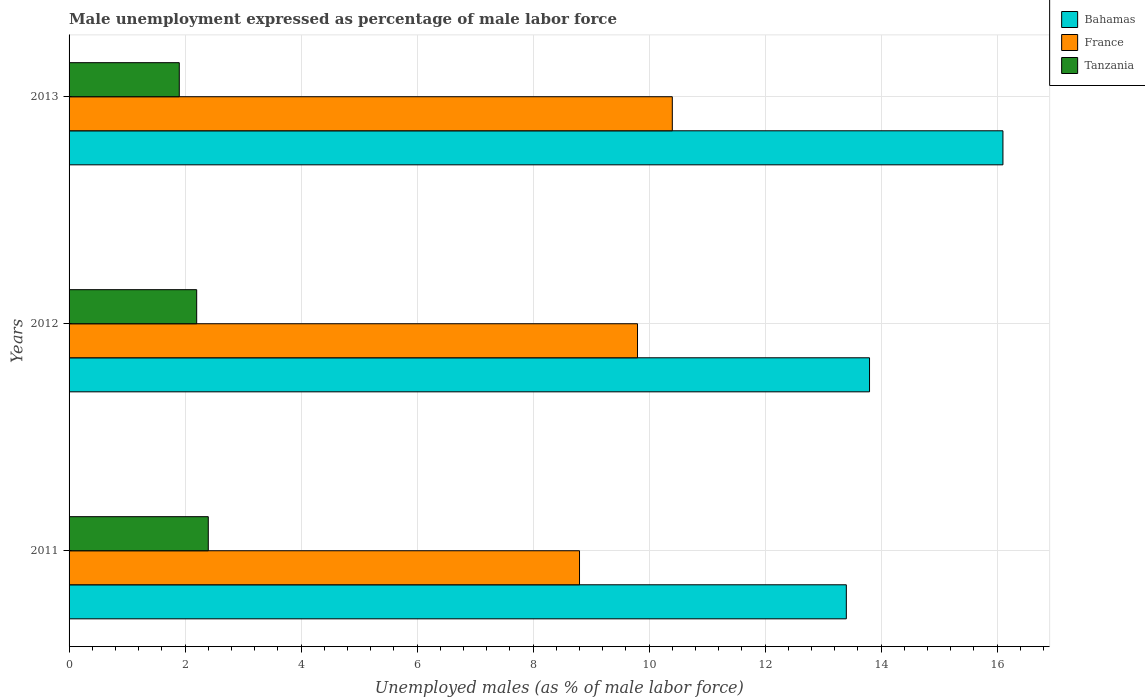How many different coloured bars are there?
Make the answer very short. 3. Are the number of bars per tick equal to the number of legend labels?
Provide a succinct answer. Yes. How many bars are there on the 2nd tick from the bottom?
Your answer should be very brief. 3. In how many cases, is the number of bars for a given year not equal to the number of legend labels?
Ensure brevity in your answer.  0. What is the unemployment in males in in France in 2012?
Make the answer very short. 9.8. Across all years, what is the maximum unemployment in males in in Tanzania?
Offer a terse response. 2.4. Across all years, what is the minimum unemployment in males in in France?
Give a very brief answer. 8.8. In which year was the unemployment in males in in Tanzania maximum?
Your answer should be very brief. 2011. In which year was the unemployment in males in in Tanzania minimum?
Your answer should be compact. 2013. What is the total unemployment in males in in Tanzania in the graph?
Offer a very short reply. 6.5. What is the difference between the unemployment in males in in Bahamas in 2011 and that in 2012?
Keep it short and to the point. -0.4. What is the difference between the unemployment in males in in Bahamas in 2011 and the unemployment in males in in Tanzania in 2013?
Your answer should be very brief. 11.5. What is the average unemployment in males in in Tanzania per year?
Give a very brief answer. 2.17. In the year 2011, what is the difference between the unemployment in males in in France and unemployment in males in in Bahamas?
Provide a succinct answer. -4.6. What is the ratio of the unemployment in males in in France in 2012 to that in 2013?
Give a very brief answer. 0.94. What is the difference between the highest and the second highest unemployment in males in in Tanzania?
Your answer should be compact. 0.2. What is the difference between the highest and the lowest unemployment in males in in Bahamas?
Keep it short and to the point. 2.7. In how many years, is the unemployment in males in in Bahamas greater than the average unemployment in males in in Bahamas taken over all years?
Your response must be concise. 1. Is the sum of the unemployment in males in in France in 2011 and 2013 greater than the maximum unemployment in males in in Tanzania across all years?
Give a very brief answer. Yes. What does the 2nd bar from the top in 2013 represents?
Give a very brief answer. France. What does the 3rd bar from the bottom in 2013 represents?
Keep it short and to the point. Tanzania. Is it the case that in every year, the sum of the unemployment in males in in Tanzania and unemployment in males in in France is greater than the unemployment in males in in Bahamas?
Your answer should be very brief. No. How many bars are there?
Offer a very short reply. 9. Are all the bars in the graph horizontal?
Ensure brevity in your answer.  Yes. Are the values on the major ticks of X-axis written in scientific E-notation?
Your response must be concise. No. Does the graph contain any zero values?
Provide a short and direct response. No. Does the graph contain grids?
Your answer should be compact. Yes. Where does the legend appear in the graph?
Your response must be concise. Top right. How are the legend labels stacked?
Provide a short and direct response. Vertical. What is the title of the graph?
Offer a terse response. Male unemployment expressed as percentage of male labor force. Does "Bhutan" appear as one of the legend labels in the graph?
Give a very brief answer. No. What is the label or title of the X-axis?
Give a very brief answer. Unemployed males (as % of male labor force). What is the label or title of the Y-axis?
Keep it short and to the point. Years. What is the Unemployed males (as % of male labor force) of Bahamas in 2011?
Ensure brevity in your answer.  13.4. What is the Unemployed males (as % of male labor force) of France in 2011?
Keep it short and to the point. 8.8. What is the Unemployed males (as % of male labor force) of Tanzania in 2011?
Provide a succinct answer. 2.4. What is the Unemployed males (as % of male labor force) of Bahamas in 2012?
Make the answer very short. 13.8. What is the Unemployed males (as % of male labor force) in France in 2012?
Your answer should be compact. 9.8. What is the Unemployed males (as % of male labor force) of Tanzania in 2012?
Give a very brief answer. 2.2. What is the Unemployed males (as % of male labor force) of Bahamas in 2013?
Keep it short and to the point. 16.1. What is the Unemployed males (as % of male labor force) of France in 2013?
Your answer should be compact. 10.4. What is the Unemployed males (as % of male labor force) of Tanzania in 2013?
Your response must be concise. 1.9. Across all years, what is the maximum Unemployed males (as % of male labor force) of Bahamas?
Make the answer very short. 16.1. Across all years, what is the maximum Unemployed males (as % of male labor force) of France?
Keep it short and to the point. 10.4. Across all years, what is the maximum Unemployed males (as % of male labor force) of Tanzania?
Provide a short and direct response. 2.4. Across all years, what is the minimum Unemployed males (as % of male labor force) of Bahamas?
Offer a very short reply. 13.4. Across all years, what is the minimum Unemployed males (as % of male labor force) of France?
Ensure brevity in your answer.  8.8. Across all years, what is the minimum Unemployed males (as % of male labor force) of Tanzania?
Your response must be concise. 1.9. What is the total Unemployed males (as % of male labor force) of Bahamas in the graph?
Provide a short and direct response. 43.3. What is the total Unemployed males (as % of male labor force) of Tanzania in the graph?
Provide a short and direct response. 6.5. What is the difference between the Unemployed males (as % of male labor force) of Bahamas in 2011 and that in 2012?
Your answer should be compact. -0.4. What is the difference between the Unemployed males (as % of male labor force) of Bahamas in 2011 and that in 2013?
Offer a terse response. -2.7. What is the difference between the Unemployed males (as % of male labor force) in France in 2011 and that in 2013?
Make the answer very short. -1.6. What is the difference between the Unemployed males (as % of male labor force) of Tanzania in 2011 and that in 2013?
Your response must be concise. 0.5. What is the difference between the Unemployed males (as % of male labor force) of Bahamas in 2011 and the Unemployed males (as % of male labor force) of France in 2012?
Provide a succinct answer. 3.6. What is the difference between the Unemployed males (as % of male labor force) in Bahamas in 2011 and the Unemployed males (as % of male labor force) in Tanzania in 2013?
Make the answer very short. 11.5. What is the difference between the Unemployed males (as % of male labor force) in France in 2011 and the Unemployed males (as % of male labor force) in Tanzania in 2013?
Provide a short and direct response. 6.9. What is the difference between the Unemployed males (as % of male labor force) in Bahamas in 2012 and the Unemployed males (as % of male labor force) in France in 2013?
Your response must be concise. 3.4. What is the difference between the Unemployed males (as % of male labor force) in Bahamas in 2012 and the Unemployed males (as % of male labor force) in Tanzania in 2013?
Make the answer very short. 11.9. What is the difference between the Unemployed males (as % of male labor force) in France in 2012 and the Unemployed males (as % of male labor force) in Tanzania in 2013?
Offer a very short reply. 7.9. What is the average Unemployed males (as % of male labor force) of Bahamas per year?
Your answer should be very brief. 14.43. What is the average Unemployed males (as % of male labor force) in France per year?
Your response must be concise. 9.67. What is the average Unemployed males (as % of male labor force) in Tanzania per year?
Your response must be concise. 2.17. In the year 2011, what is the difference between the Unemployed males (as % of male labor force) of Bahamas and Unemployed males (as % of male labor force) of Tanzania?
Your answer should be very brief. 11. In the year 2011, what is the difference between the Unemployed males (as % of male labor force) of France and Unemployed males (as % of male labor force) of Tanzania?
Provide a succinct answer. 6.4. In the year 2012, what is the difference between the Unemployed males (as % of male labor force) in Bahamas and Unemployed males (as % of male labor force) in France?
Provide a short and direct response. 4. In the year 2013, what is the difference between the Unemployed males (as % of male labor force) of Bahamas and Unemployed males (as % of male labor force) of France?
Give a very brief answer. 5.7. What is the ratio of the Unemployed males (as % of male labor force) in France in 2011 to that in 2012?
Ensure brevity in your answer.  0.9. What is the ratio of the Unemployed males (as % of male labor force) of Tanzania in 2011 to that in 2012?
Offer a very short reply. 1.09. What is the ratio of the Unemployed males (as % of male labor force) in Bahamas in 2011 to that in 2013?
Your answer should be compact. 0.83. What is the ratio of the Unemployed males (as % of male labor force) in France in 2011 to that in 2013?
Give a very brief answer. 0.85. What is the ratio of the Unemployed males (as % of male labor force) in Tanzania in 2011 to that in 2013?
Your answer should be very brief. 1.26. What is the ratio of the Unemployed males (as % of male labor force) of Bahamas in 2012 to that in 2013?
Provide a succinct answer. 0.86. What is the ratio of the Unemployed males (as % of male labor force) in France in 2012 to that in 2013?
Your response must be concise. 0.94. What is the ratio of the Unemployed males (as % of male labor force) in Tanzania in 2012 to that in 2013?
Offer a terse response. 1.16. What is the difference between the highest and the lowest Unemployed males (as % of male labor force) in France?
Make the answer very short. 1.6. What is the difference between the highest and the lowest Unemployed males (as % of male labor force) of Tanzania?
Your response must be concise. 0.5. 